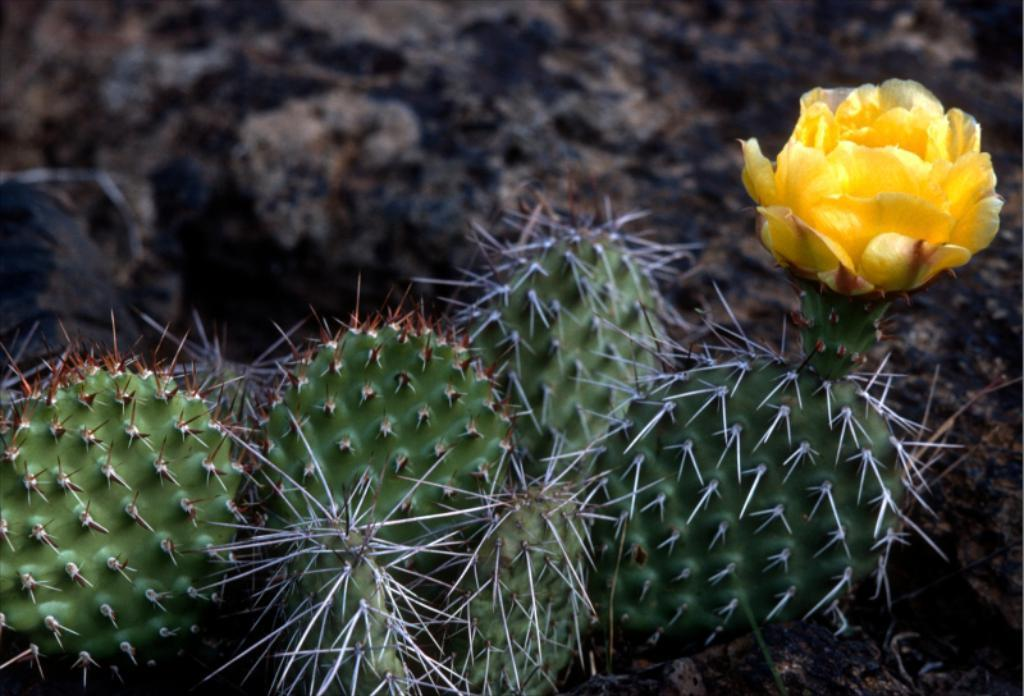What type of plant can be seen in the image? There is a cactus in the image. What other type of plant is present in the image? There is a flower in the image. What color is the flower? The flower is yellow in color. What type of selection process did the cactus go through to be featured in the image? There is no indication in the image that the cactus went through a selection process to be featured; it is simply present in the image. 